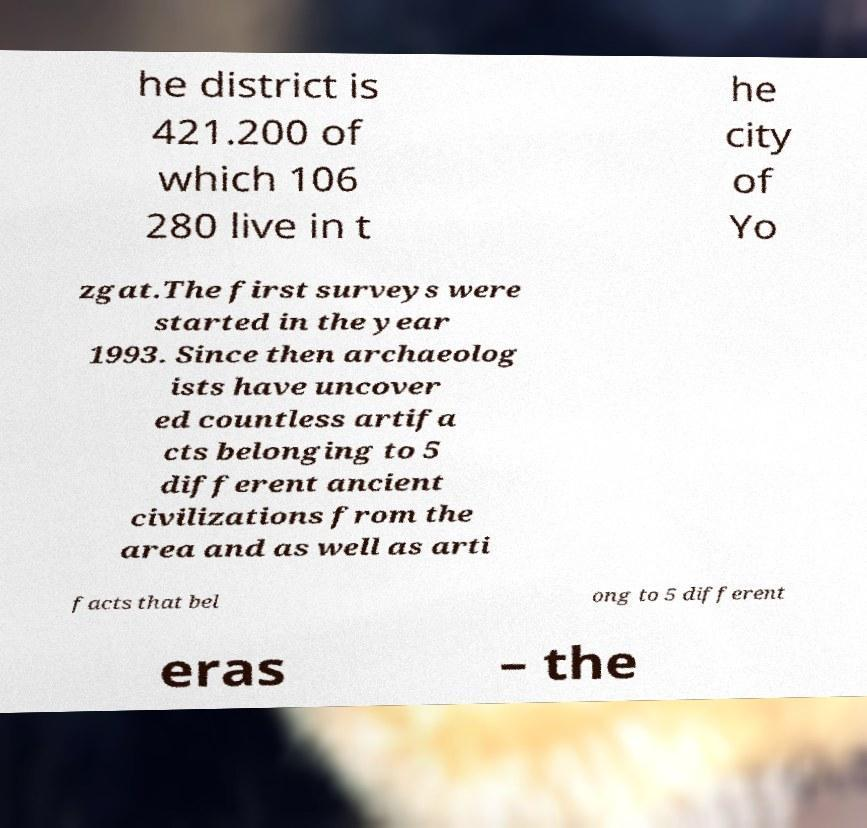Please identify and transcribe the text found in this image. he district is 421.200 of which 106 280 live in t he city of Yo zgat.The first surveys were started in the year 1993. Since then archaeolog ists have uncover ed countless artifa cts belonging to 5 different ancient civilizations from the area and as well as arti facts that bel ong to 5 different eras – the 